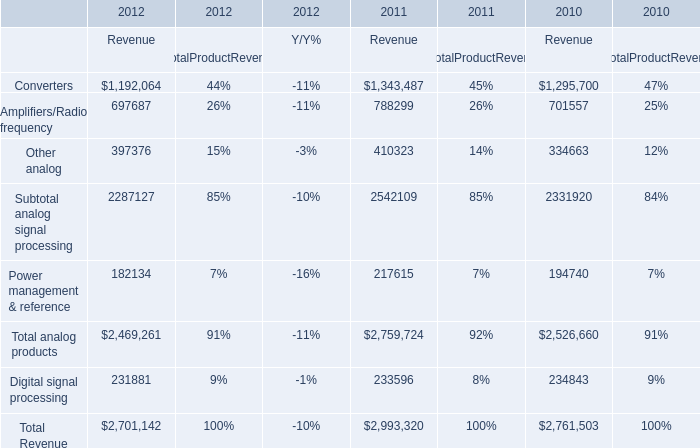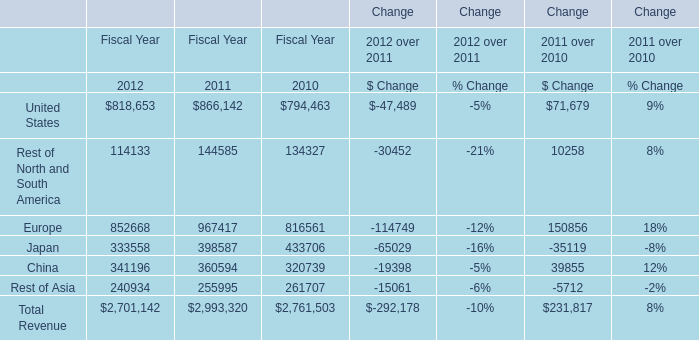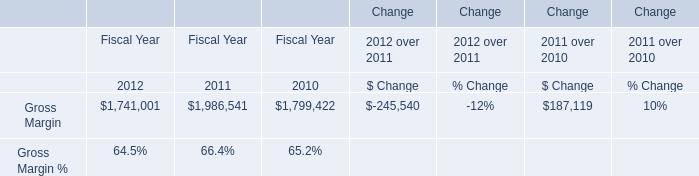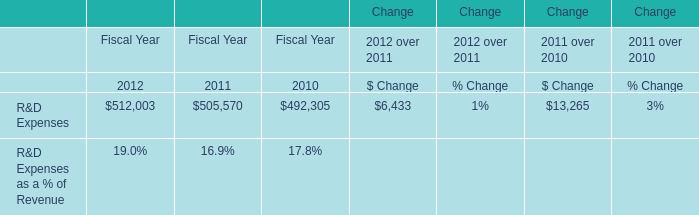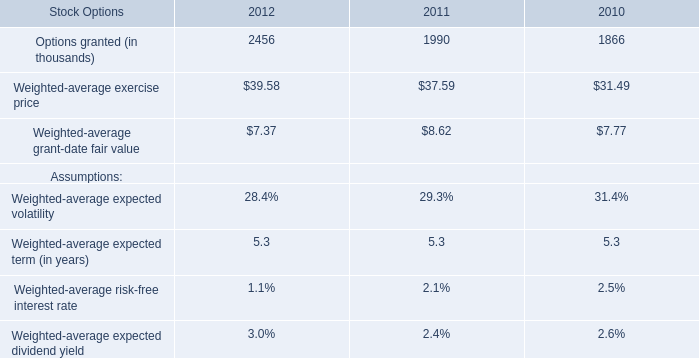What is the growing rate of Total analog products in the year with the most Total Revenue？ 
Computations: ((2469261 - 2759724) / 2759724)
Answer: -0.10525. 